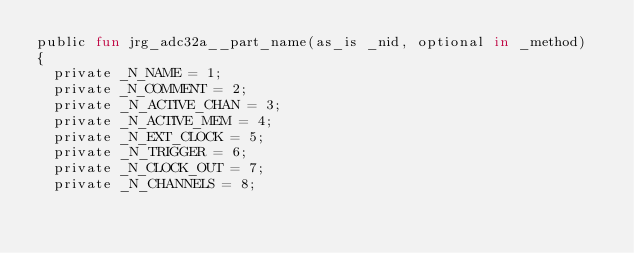Convert code to text. <code><loc_0><loc_0><loc_500><loc_500><_SML_>public fun jrg_adc32a__part_name(as_is _nid, optional in _method)
{
  private _N_NAME = 1;
  private _N_COMMENT = 2;
  private _N_ACTIVE_CHAN = 3;
  private _N_ACTIVE_MEM = 4;
  private _N_EXT_CLOCK = 5;
  private _N_TRIGGER = 6;
  private _N_CLOCK_OUT = 7;
  private _N_CHANNELS = 8;</code> 